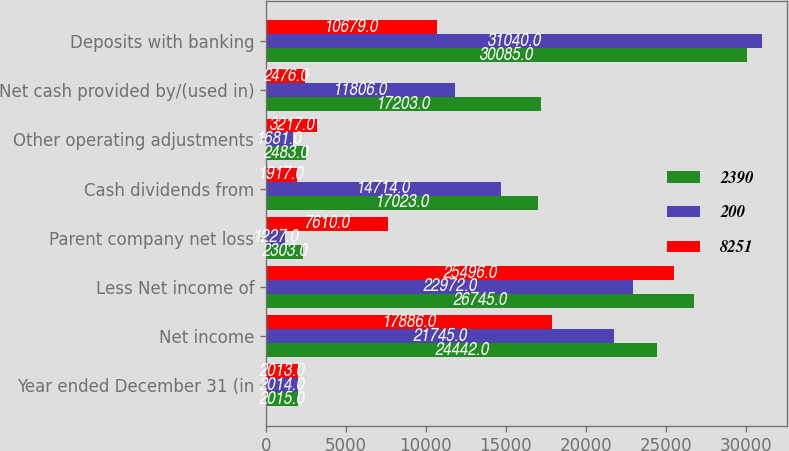<chart> <loc_0><loc_0><loc_500><loc_500><stacked_bar_chart><ecel><fcel>Year ended December 31 (in<fcel>Net income<fcel>Less Net income of<fcel>Parent company net loss<fcel>Cash dividends from<fcel>Other operating adjustments<fcel>Net cash provided by/(used in)<fcel>Deposits with banking<nl><fcel>2390<fcel>2015<fcel>24442<fcel>26745<fcel>2303<fcel>17023<fcel>2483<fcel>17203<fcel>30085<nl><fcel>200<fcel>2014<fcel>21745<fcel>22972<fcel>1227<fcel>14714<fcel>1681<fcel>11806<fcel>31040<nl><fcel>8251<fcel>2013<fcel>17886<fcel>25496<fcel>7610<fcel>1917<fcel>3217<fcel>2476<fcel>10679<nl></chart> 